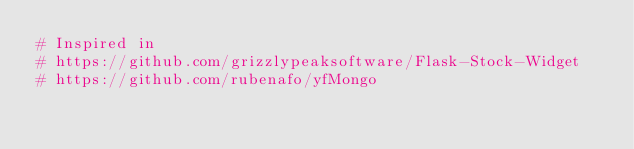<code> <loc_0><loc_0><loc_500><loc_500><_Python_># Inspired in
# https://github.com/grizzlypeaksoftware/Flask-Stock-Widget
# https://github.com/rubenafo/yfMongo
</code> 